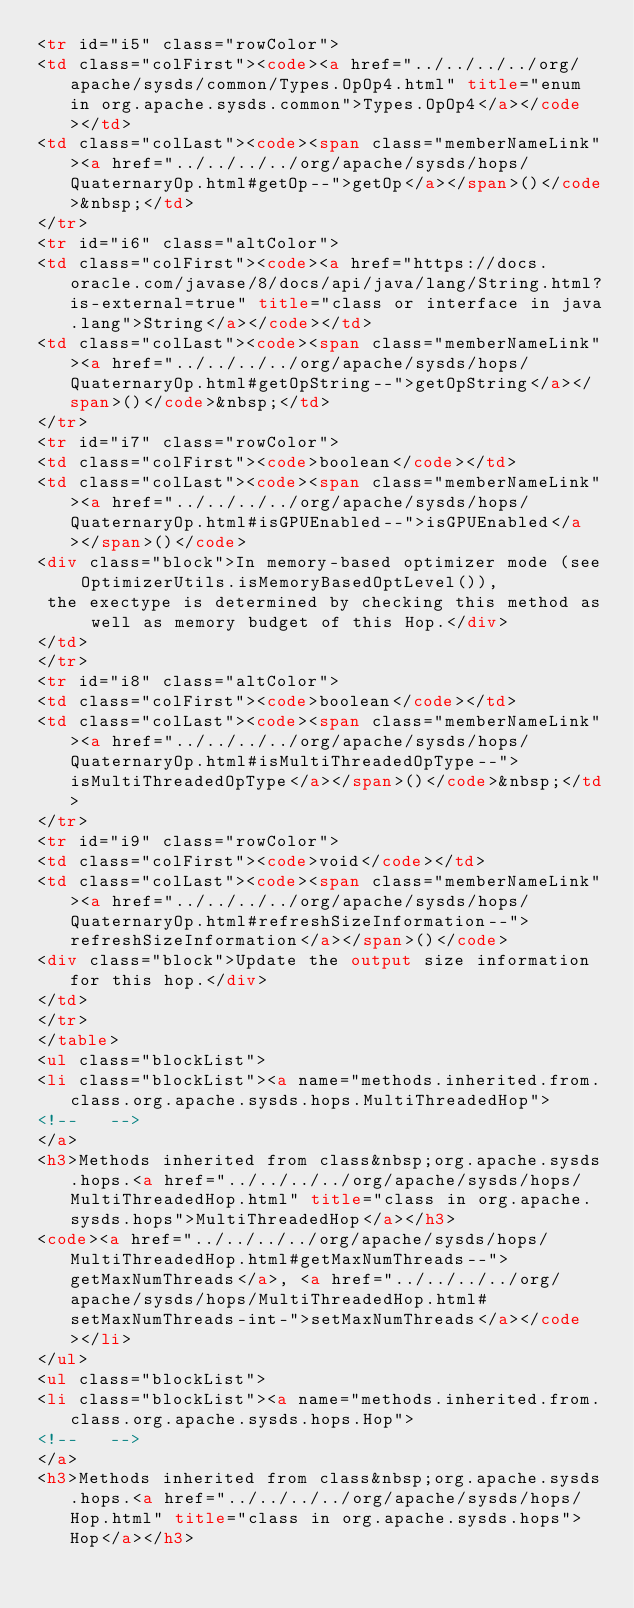Convert code to text. <code><loc_0><loc_0><loc_500><loc_500><_HTML_><tr id="i5" class="rowColor">
<td class="colFirst"><code><a href="../../../../org/apache/sysds/common/Types.OpOp4.html" title="enum in org.apache.sysds.common">Types.OpOp4</a></code></td>
<td class="colLast"><code><span class="memberNameLink"><a href="../../../../org/apache/sysds/hops/QuaternaryOp.html#getOp--">getOp</a></span>()</code>&nbsp;</td>
</tr>
<tr id="i6" class="altColor">
<td class="colFirst"><code><a href="https://docs.oracle.com/javase/8/docs/api/java/lang/String.html?is-external=true" title="class or interface in java.lang">String</a></code></td>
<td class="colLast"><code><span class="memberNameLink"><a href="../../../../org/apache/sysds/hops/QuaternaryOp.html#getOpString--">getOpString</a></span>()</code>&nbsp;</td>
</tr>
<tr id="i7" class="rowColor">
<td class="colFirst"><code>boolean</code></td>
<td class="colLast"><code><span class="memberNameLink"><a href="../../../../org/apache/sysds/hops/QuaternaryOp.html#isGPUEnabled--">isGPUEnabled</a></span>()</code>
<div class="block">In memory-based optimizer mode (see OptimizerUtils.isMemoryBasedOptLevel()), 
 the exectype is determined by checking this method as well as memory budget of this Hop.</div>
</td>
</tr>
<tr id="i8" class="altColor">
<td class="colFirst"><code>boolean</code></td>
<td class="colLast"><code><span class="memberNameLink"><a href="../../../../org/apache/sysds/hops/QuaternaryOp.html#isMultiThreadedOpType--">isMultiThreadedOpType</a></span>()</code>&nbsp;</td>
</tr>
<tr id="i9" class="rowColor">
<td class="colFirst"><code>void</code></td>
<td class="colLast"><code><span class="memberNameLink"><a href="../../../../org/apache/sysds/hops/QuaternaryOp.html#refreshSizeInformation--">refreshSizeInformation</a></span>()</code>
<div class="block">Update the output size information for this hop.</div>
</td>
</tr>
</table>
<ul class="blockList">
<li class="blockList"><a name="methods.inherited.from.class.org.apache.sysds.hops.MultiThreadedHop">
<!--   -->
</a>
<h3>Methods inherited from class&nbsp;org.apache.sysds.hops.<a href="../../../../org/apache/sysds/hops/MultiThreadedHop.html" title="class in org.apache.sysds.hops">MultiThreadedHop</a></h3>
<code><a href="../../../../org/apache/sysds/hops/MultiThreadedHop.html#getMaxNumThreads--">getMaxNumThreads</a>, <a href="../../../../org/apache/sysds/hops/MultiThreadedHop.html#setMaxNumThreads-int-">setMaxNumThreads</a></code></li>
</ul>
<ul class="blockList">
<li class="blockList"><a name="methods.inherited.from.class.org.apache.sysds.hops.Hop">
<!--   -->
</a>
<h3>Methods inherited from class&nbsp;org.apache.sysds.hops.<a href="../../../../org/apache/sysds/hops/Hop.html" title="class in org.apache.sysds.hops">Hop</a></h3></code> 